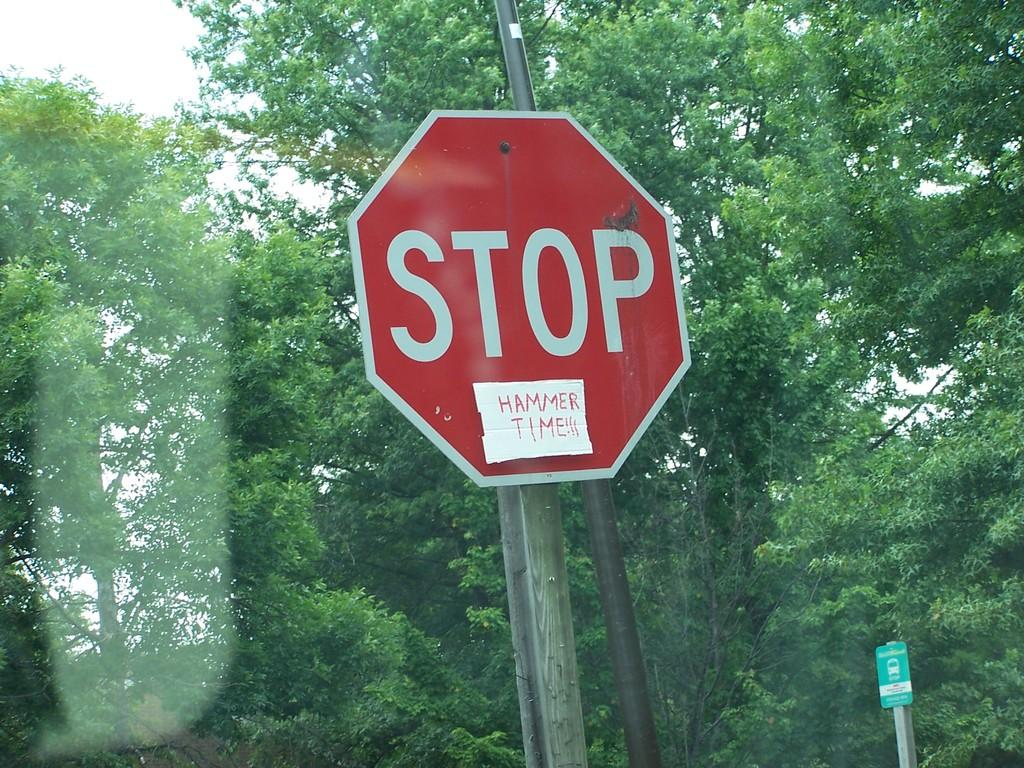<image>
Write a terse but informative summary of the picture. A stop sign has been altered to say Stop Hammer Time. 